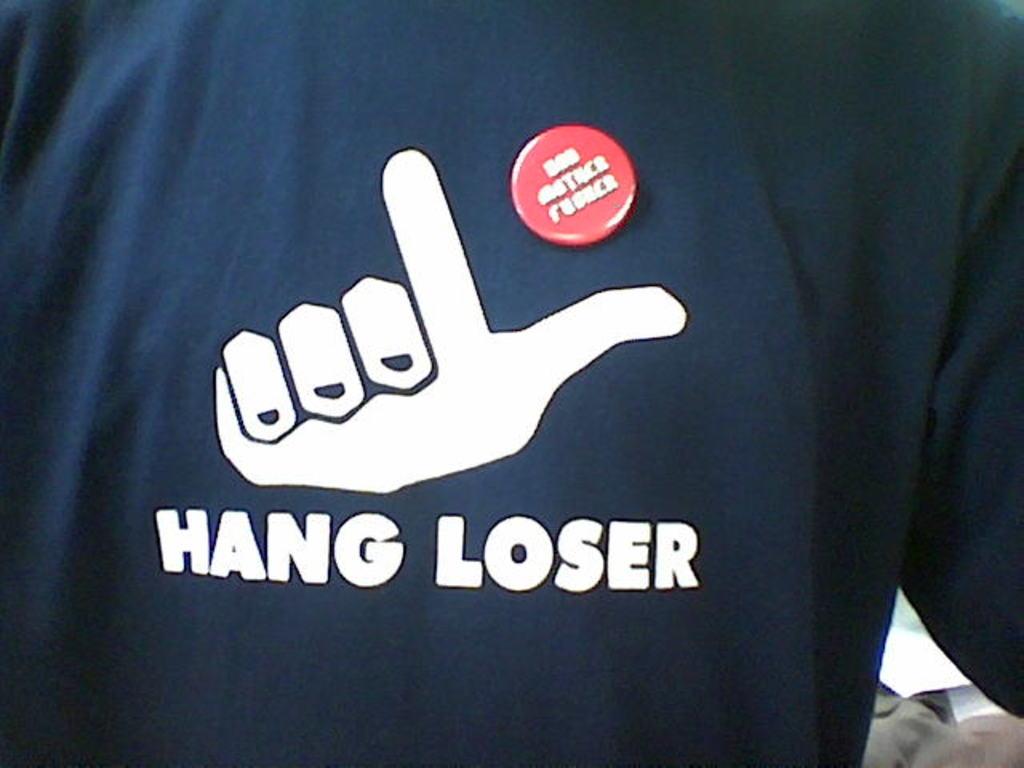What do loser do?
Your response must be concise. Hang. 